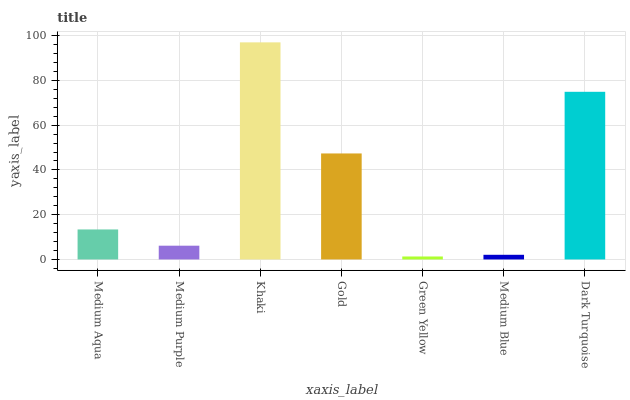Is Green Yellow the minimum?
Answer yes or no. Yes. Is Khaki the maximum?
Answer yes or no. Yes. Is Medium Purple the minimum?
Answer yes or no. No. Is Medium Purple the maximum?
Answer yes or no. No. Is Medium Aqua greater than Medium Purple?
Answer yes or no. Yes. Is Medium Purple less than Medium Aqua?
Answer yes or no. Yes. Is Medium Purple greater than Medium Aqua?
Answer yes or no. No. Is Medium Aqua less than Medium Purple?
Answer yes or no. No. Is Medium Aqua the high median?
Answer yes or no. Yes. Is Medium Aqua the low median?
Answer yes or no. Yes. Is Gold the high median?
Answer yes or no. No. Is Khaki the low median?
Answer yes or no. No. 